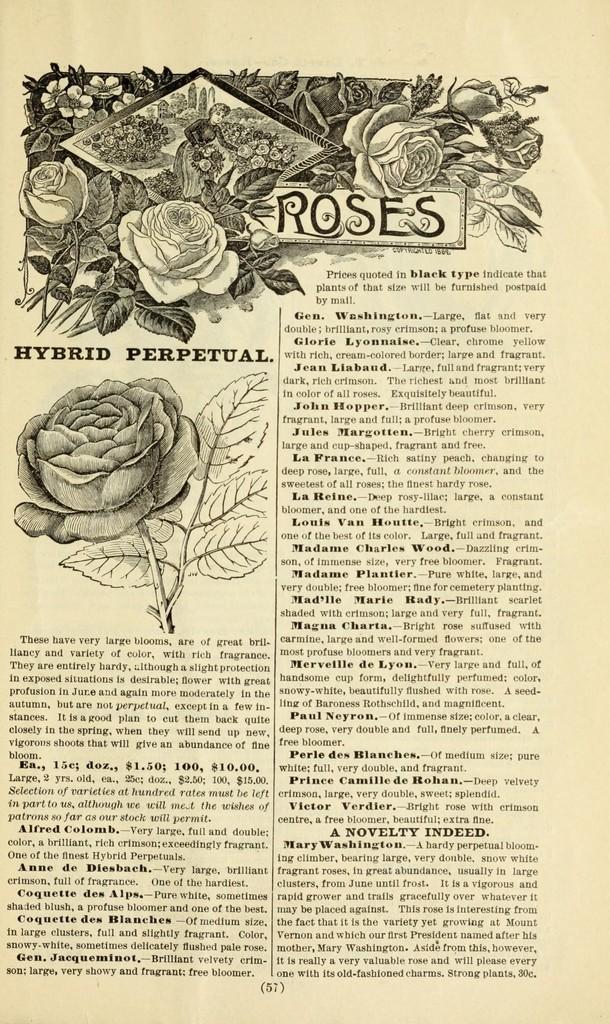Please provide a concise description of this image. In this image we can see there is a paper and some text written on it. And there are roses and a person's picture drawn on it. 